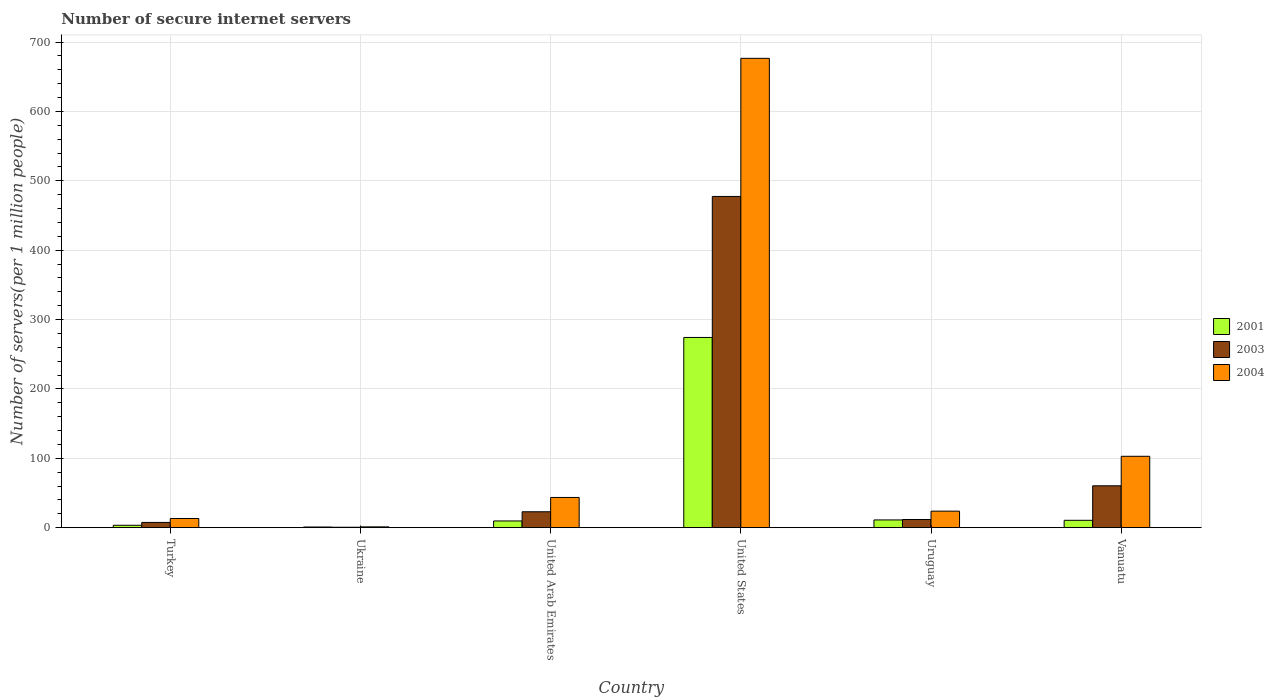How many different coloured bars are there?
Provide a short and direct response. 3. Are the number of bars per tick equal to the number of legend labels?
Ensure brevity in your answer.  Yes. How many bars are there on the 1st tick from the left?
Give a very brief answer. 3. How many bars are there on the 3rd tick from the right?
Offer a terse response. 3. What is the number of secure internet servers in 2003 in United States?
Provide a short and direct response. 477.46. Across all countries, what is the maximum number of secure internet servers in 2004?
Offer a very short reply. 676.55. Across all countries, what is the minimum number of secure internet servers in 2003?
Ensure brevity in your answer.  0.59. In which country was the number of secure internet servers in 2004 maximum?
Keep it short and to the point. United States. In which country was the number of secure internet servers in 2004 minimum?
Provide a short and direct response. Ukraine. What is the total number of secure internet servers in 2004 in the graph?
Your response must be concise. 860.98. What is the difference between the number of secure internet servers in 2001 in Turkey and that in Uruguay?
Give a very brief answer. -7.71. What is the difference between the number of secure internet servers in 2001 in Vanuatu and the number of secure internet servers in 2003 in Turkey?
Keep it short and to the point. 3.06. What is the average number of secure internet servers in 2001 per country?
Ensure brevity in your answer.  51.63. What is the difference between the number of secure internet servers of/in 2004 and number of secure internet servers of/in 2003 in Uruguay?
Provide a succinct answer. 12.04. What is the ratio of the number of secure internet servers in 2004 in Ukraine to that in United Arab Emirates?
Provide a succinct answer. 0.03. Is the difference between the number of secure internet servers in 2004 in Ukraine and Uruguay greater than the difference between the number of secure internet servers in 2003 in Ukraine and Uruguay?
Your response must be concise. No. What is the difference between the highest and the second highest number of secure internet servers in 2001?
Offer a terse response. 263.04. What is the difference between the highest and the lowest number of secure internet servers in 2001?
Make the answer very short. 273.25. What does the 2nd bar from the left in Uruguay represents?
Provide a short and direct response. 2003. How many bars are there?
Give a very brief answer. 18. Are all the bars in the graph horizontal?
Make the answer very short. No. How many countries are there in the graph?
Your response must be concise. 6. Are the values on the major ticks of Y-axis written in scientific E-notation?
Ensure brevity in your answer.  No. Does the graph contain any zero values?
Keep it short and to the point. No. How are the legend labels stacked?
Provide a short and direct response. Vertical. What is the title of the graph?
Your answer should be compact. Number of secure internet servers. Does "1978" appear as one of the legend labels in the graph?
Offer a very short reply. No. What is the label or title of the Y-axis?
Provide a short and direct response. Number of servers(per 1 million people). What is the Number of servers(per 1 million people) in 2001 in Turkey?
Ensure brevity in your answer.  3.41. What is the Number of servers(per 1 million people) in 2003 in Turkey?
Make the answer very short. 7.51. What is the Number of servers(per 1 million people) of 2004 in Turkey?
Provide a short and direct response. 13.17. What is the Number of servers(per 1 million people) of 2001 in Ukraine?
Your answer should be compact. 0.9. What is the Number of servers(per 1 million people) of 2003 in Ukraine?
Offer a terse response. 0.59. What is the Number of servers(per 1 million people) in 2004 in Ukraine?
Give a very brief answer. 1.12. What is the Number of servers(per 1 million people) in 2001 in United Arab Emirates?
Your response must be concise. 9.63. What is the Number of servers(per 1 million people) in 2003 in United Arab Emirates?
Make the answer very short. 22.89. What is the Number of servers(per 1 million people) of 2004 in United Arab Emirates?
Your response must be concise. 43.51. What is the Number of servers(per 1 million people) of 2001 in United States?
Provide a succinct answer. 274.16. What is the Number of servers(per 1 million people) in 2003 in United States?
Your answer should be very brief. 477.46. What is the Number of servers(per 1 million people) of 2004 in United States?
Provide a short and direct response. 676.55. What is the Number of servers(per 1 million people) of 2001 in Uruguay?
Your answer should be very brief. 11.12. What is the Number of servers(per 1 million people) in 2003 in Uruguay?
Offer a very short reply. 11.73. What is the Number of servers(per 1 million people) in 2004 in Uruguay?
Make the answer very short. 23.77. What is the Number of servers(per 1 million people) in 2001 in Vanuatu?
Offer a terse response. 10.57. What is the Number of servers(per 1 million people) of 2003 in Vanuatu?
Provide a short and direct response. 60.31. What is the Number of servers(per 1 million people) of 2004 in Vanuatu?
Offer a very short reply. 102.87. Across all countries, what is the maximum Number of servers(per 1 million people) in 2001?
Keep it short and to the point. 274.16. Across all countries, what is the maximum Number of servers(per 1 million people) in 2003?
Your answer should be very brief. 477.46. Across all countries, what is the maximum Number of servers(per 1 million people) in 2004?
Make the answer very short. 676.55. Across all countries, what is the minimum Number of servers(per 1 million people) in 2001?
Ensure brevity in your answer.  0.9. Across all countries, what is the minimum Number of servers(per 1 million people) in 2003?
Offer a very short reply. 0.59. Across all countries, what is the minimum Number of servers(per 1 million people) in 2004?
Keep it short and to the point. 1.12. What is the total Number of servers(per 1 million people) in 2001 in the graph?
Provide a succinct answer. 309.79. What is the total Number of servers(per 1 million people) of 2003 in the graph?
Your answer should be very brief. 580.48. What is the total Number of servers(per 1 million people) in 2004 in the graph?
Your answer should be very brief. 860.98. What is the difference between the Number of servers(per 1 million people) in 2001 in Turkey and that in Ukraine?
Make the answer very short. 2.51. What is the difference between the Number of servers(per 1 million people) of 2003 in Turkey and that in Ukraine?
Keep it short and to the point. 6.92. What is the difference between the Number of servers(per 1 million people) in 2004 in Turkey and that in Ukraine?
Ensure brevity in your answer.  12.05. What is the difference between the Number of servers(per 1 million people) in 2001 in Turkey and that in United Arab Emirates?
Offer a terse response. -6.22. What is the difference between the Number of servers(per 1 million people) of 2003 in Turkey and that in United Arab Emirates?
Offer a very short reply. -15.38. What is the difference between the Number of servers(per 1 million people) of 2004 in Turkey and that in United Arab Emirates?
Make the answer very short. -30.34. What is the difference between the Number of servers(per 1 million people) in 2001 in Turkey and that in United States?
Ensure brevity in your answer.  -270.74. What is the difference between the Number of servers(per 1 million people) in 2003 in Turkey and that in United States?
Keep it short and to the point. -469.95. What is the difference between the Number of servers(per 1 million people) of 2004 in Turkey and that in United States?
Keep it short and to the point. -663.38. What is the difference between the Number of servers(per 1 million people) of 2001 in Turkey and that in Uruguay?
Your response must be concise. -7.71. What is the difference between the Number of servers(per 1 million people) in 2003 in Turkey and that in Uruguay?
Give a very brief answer. -4.22. What is the difference between the Number of servers(per 1 million people) in 2004 in Turkey and that in Uruguay?
Offer a very short reply. -10.6. What is the difference between the Number of servers(per 1 million people) in 2001 in Turkey and that in Vanuatu?
Provide a succinct answer. -7.15. What is the difference between the Number of servers(per 1 million people) in 2003 in Turkey and that in Vanuatu?
Give a very brief answer. -52.8. What is the difference between the Number of servers(per 1 million people) in 2004 in Turkey and that in Vanuatu?
Offer a terse response. -89.7. What is the difference between the Number of servers(per 1 million people) in 2001 in Ukraine and that in United Arab Emirates?
Provide a succinct answer. -8.73. What is the difference between the Number of servers(per 1 million people) of 2003 in Ukraine and that in United Arab Emirates?
Make the answer very short. -22.31. What is the difference between the Number of servers(per 1 million people) of 2004 in Ukraine and that in United Arab Emirates?
Offer a very short reply. -42.39. What is the difference between the Number of servers(per 1 million people) of 2001 in Ukraine and that in United States?
Keep it short and to the point. -273.25. What is the difference between the Number of servers(per 1 million people) in 2003 in Ukraine and that in United States?
Provide a succinct answer. -476.87. What is the difference between the Number of servers(per 1 million people) in 2004 in Ukraine and that in United States?
Your response must be concise. -675.43. What is the difference between the Number of servers(per 1 million people) in 2001 in Ukraine and that in Uruguay?
Your response must be concise. -10.22. What is the difference between the Number of servers(per 1 million people) of 2003 in Ukraine and that in Uruguay?
Give a very brief answer. -11.14. What is the difference between the Number of servers(per 1 million people) of 2004 in Ukraine and that in Uruguay?
Give a very brief answer. -22.65. What is the difference between the Number of servers(per 1 million people) in 2001 in Ukraine and that in Vanuatu?
Your answer should be compact. -9.66. What is the difference between the Number of servers(per 1 million people) of 2003 in Ukraine and that in Vanuatu?
Your response must be concise. -59.73. What is the difference between the Number of servers(per 1 million people) of 2004 in Ukraine and that in Vanuatu?
Offer a terse response. -101.75. What is the difference between the Number of servers(per 1 million people) in 2001 in United Arab Emirates and that in United States?
Your response must be concise. -264.52. What is the difference between the Number of servers(per 1 million people) in 2003 in United Arab Emirates and that in United States?
Provide a succinct answer. -454.57. What is the difference between the Number of servers(per 1 million people) in 2004 in United Arab Emirates and that in United States?
Give a very brief answer. -633.04. What is the difference between the Number of servers(per 1 million people) of 2001 in United Arab Emirates and that in Uruguay?
Provide a succinct answer. -1.49. What is the difference between the Number of servers(per 1 million people) in 2003 in United Arab Emirates and that in Uruguay?
Provide a short and direct response. 11.16. What is the difference between the Number of servers(per 1 million people) of 2004 in United Arab Emirates and that in Uruguay?
Ensure brevity in your answer.  19.75. What is the difference between the Number of servers(per 1 million people) of 2001 in United Arab Emirates and that in Vanuatu?
Provide a short and direct response. -0.93. What is the difference between the Number of servers(per 1 million people) of 2003 in United Arab Emirates and that in Vanuatu?
Provide a succinct answer. -37.42. What is the difference between the Number of servers(per 1 million people) in 2004 in United Arab Emirates and that in Vanuatu?
Ensure brevity in your answer.  -59.36. What is the difference between the Number of servers(per 1 million people) in 2001 in United States and that in Uruguay?
Give a very brief answer. 263.04. What is the difference between the Number of servers(per 1 million people) of 2003 in United States and that in Uruguay?
Provide a succinct answer. 465.73. What is the difference between the Number of servers(per 1 million people) in 2004 in United States and that in Uruguay?
Provide a succinct answer. 652.79. What is the difference between the Number of servers(per 1 million people) in 2001 in United States and that in Vanuatu?
Keep it short and to the point. 263.59. What is the difference between the Number of servers(per 1 million people) in 2003 in United States and that in Vanuatu?
Ensure brevity in your answer.  417.14. What is the difference between the Number of servers(per 1 million people) of 2004 in United States and that in Vanuatu?
Provide a short and direct response. 573.68. What is the difference between the Number of servers(per 1 million people) of 2001 in Uruguay and that in Vanuatu?
Provide a succinct answer. 0.55. What is the difference between the Number of servers(per 1 million people) in 2003 in Uruguay and that in Vanuatu?
Ensure brevity in your answer.  -48.59. What is the difference between the Number of servers(per 1 million people) in 2004 in Uruguay and that in Vanuatu?
Your response must be concise. -79.1. What is the difference between the Number of servers(per 1 million people) of 2001 in Turkey and the Number of servers(per 1 million people) of 2003 in Ukraine?
Your answer should be compact. 2.83. What is the difference between the Number of servers(per 1 million people) in 2001 in Turkey and the Number of servers(per 1 million people) in 2004 in Ukraine?
Keep it short and to the point. 2.3. What is the difference between the Number of servers(per 1 million people) in 2003 in Turkey and the Number of servers(per 1 million people) in 2004 in Ukraine?
Give a very brief answer. 6.39. What is the difference between the Number of servers(per 1 million people) of 2001 in Turkey and the Number of servers(per 1 million people) of 2003 in United Arab Emirates?
Your response must be concise. -19.48. What is the difference between the Number of servers(per 1 million people) in 2001 in Turkey and the Number of servers(per 1 million people) in 2004 in United Arab Emirates?
Give a very brief answer. -40.1. What is the difference between the Number of servers(per 1 million people) in 2003 in Turkey and the Number of servers(per 1 million people) in 2004 in United Arab Emirates?
Give a very brief answer. -36. What is the difference between the Number of servers(per 1 million people) of 2001 in Turkey and the Number of servers(per 1 million people) of 2003 in United States?
Provide a short and direct response. -474.04. What is the difference between the Number of servers(per 1 million people) of 2001 in Turkey and the Number of servers(per 1 million people) of 2004 in United States?
Your answer should be very brief. -673.14. What is the difference between the Number of servers(per 1 million people) in 2003 in Turkey and the Number of servers(per 1 million people) in 2004 in United States?
Keep it short and to the point. -669.04. What is the difference between the Number of servers(per 1 million people) of 2001 in Turkey and the Number of servers(per 1 million people) of 2003 in Uruguay?
Your answer should be very brief. -8.31. What is the difference between the Number of servers(per 1 million people) of 2001 in Turkey and the Number of servers(per 1 million people) of 2004 in Uruguay?
Keep it short and to the point. -20.35. What is the difference between the Number of servers(per 1 million people) of 2003 in Turkey and the Number of servers(per 1 million people) of 2004 in Uruguay?
Provide a succinct answer. -16.26. What is the difference between the Number of servers(per 1 million people) in 2001 in Turkey and the Number of servers(per 1 million people) in 2003 in Vanuatu?
Make the answer very short. -56.9. What is the difference between the Number of servers(per 1 million people) of 2001 in Turkey and the Number of servers(per 1 million people) of 2004 in Vanuatu?
Provide a short and direct response. -99.46. What is the difference between the Number of servers(per 1 million people) of 2003 in Turkey and the Number of servers(per 1 million people) of 2004 in Vanuatu?
Offer a terse response. -95.36. What is the difference between the Number of servers(per 1 million people) of 2001 in Ukraine and the Number of servers(per 1 million people) of 2003 in United Arab Emirates?
Offer a terse response. -21.99. What is the difference between the Number of servers(per 1 million people) in 2001 in Ukraine and the Number of servers(per 1 million people) in 2004 in United Arab Emirates?
Offer a terse response. -42.61. What is the difference between the Number of servers(per 1 million people) of 2003 in Ukraine and the Number of servers(per 1 million people) of 2004 in United Arab Emirates?
Keep it short and to the point. -42.93. What is the difference between the Number of servers(per 1 million people) in 2001 in Ukraine and the Number of servers(per 1 million people) in 2003 in United States?
Provide a succinct answer. -476.55. What is the difference between the Number of servers(per 1 million people) of 2001 in Ukraine and the Number of servers(per 1 million people) of 2004 in United States?
Your answer should be compact. -675.65. What is the difference between the Number of servers(per 1 million people) of 2003 in Ukraine and the Number of servers(per 1 million people) of 2004 in United States?
Your answer should be compact. -675.97. What is the difference between the Number of servers(per 1 million people) of 2001 in Ukraine and the Number of servers(per 1 million people) of 2003 in Uruguay?
Provide a succinct answer. -10.82. What is the difference between the Number of servers(per 1 million people) of 2001 in Ukraine and the Number of servers(per 1 million people) of 2004 in Uruguay?
Provide a succinct answer. -22.86. What is the difference between the Number of servers(per 1 million people) of 2003 in Ukraine and the Number of servers(per 1 million people) of 2004 in Uruguay?
Offer a terse response. -23.18. What is the difference between the Number of servers(per 1 million people) in 2001 in Ukraine and the Number of servers(per 1 million people) in 2003 in Vanuatu?
Give a very brief answer. -59.41. What is the difference between the Number of servers(per 1 million people) of 2001 in Ukraine and the Number of servers(per 1 million people) of 2004 in Vanuatu?
Your response must be concise. -101.96. What is the difference between the Number of servers(per 1 million people) of 2003 in Ukraine and the Number of servers(per 1 million people) of 2004 in Vanuatu?
Offer a terse response. -102.28. What is the difference between the Number of servers(per 1 million people) in 2001 in United Arab Emirates and the Number of servers(per 1 million people) in 2003 in United States?
Your answer should be very brief. -467.82. What is the difference between the Number of servers(per 1 million people) of 2001 in United Arab Emirates and the Number of servers(per 1 million people) of 2004 in United States?
Make the answer very short. -666.92. What is the difference between the Number of servers(per 1 million people) of 2003 in United Arab Emirates and the Number of servers(per 1 million people) of 2004 in United States?
Provide a short and direct response. -653.66. What is the difference between the Number of servers(per 1 million people) in 2001 in United Arab Emirates and the Number of servers(per 1 million people) in 2003 in Uruguay?
Offer a terse response. -2.09. What is the difference between the Number of servers(per 1 million people) of 2001 in United Arab Emirates and the Number of servers(per 1 million people) of 2004 in Uruguay?
Your answer should be compact. -14.13. What is the difference between the Number of servers(per 1 million people) in 2003 in United Arab Emirates and the Number of servers(per 1 million people) in 2004 in Uruguay?
Provide a short and direct response. -0.87. What is the difference between the Number of servers(per 1 million people) of 2001 in United Arab Emirates and the Number of servers(per 1 million people) of 2003 in Vanuatu?
Provide a succinct answer. -50.68. What is the difference between the Number of servers(per 1 million people) of 2001 in United Arab Emirates and the Number of servers(per 1 million people) of 2004 in Vanuatu?
Offer a very short reply. -93.23. What is the difference between the Number of servers(per 1 million people) of 2003 in United Arab Emirates and the Number of servers(per 1 million people) of 2004 in Vanuatu?
Provide a succinct answer. -79.98. What is the difference between the Number of servers(per 1 million people) of 2001 in United States and the Number of servers(per 1 million people) of 2003 in Uruguay?
Make the answer very short. 262.43. What is the difference between the Number of servers(per 1 million people) in 2001 in United States and the Number of servers(per 1 million people) in 2004 in Uruguay?
Ensure brevity in your answer.  250.39. What is the difference between the Number of servers(per 1 million people) in 2003 in United States and the Number of servers(per 1 million people) in 2004 in Uruguay?
Make the answer very short. 453.69. What is the difference between the Number of servers(per 1 million people) in 2001 in United States and the Number of servers(per 1 million people) in 2003 in Vanuatu?
Provide a succinct answer. 213.84. What is the difference between the Number of servers(per 1 million people) of 2001 in United States and the Number of servers(per 1 million people) of 2004 in Vanuatu?
Provide a succinct answer. 171.29. What is the difference between the Number of servers(per 1 million people) of 2003 in United States and the Number of servers(per 1 million people) of 2004 in Vanuatu?
Your response must be concise. 374.59. What is the difference between the Number of servers(per 1 million people) in 2001 in Uruguay and the Number of servers(per 1 million people) in 2003 in Vanuatu?
Your answer should be compact. -49.19. What is the difference between the Number of servers(per 1 million people) in 2001 in Uruguay and the Number of servers(per 1 million people) in 2004 in Vanuatu?
Keep it short and to the point. -91.75. What is the difference between the Number of servers(per 1 million people) in 2003 in Uruguay and the Number of servers(per 1 million people) in 2004 in Vanuatu?
Your response must be concise. -91.14. What is the average Number of servers(per 1 million people) of 2001 per country?
Provide a succinct answer. 51.63. What is the average Number of servers(per 1 million people) in 2003 per country?
Your response must be concise. 96.75. What is the average Number of servers(per 1 million people) of 2004 per country?
Your response must be concise. 143.5. What is the difference between the Number of servers(per 1 million people) in 2001 and Number of servers(per 1 million people) in 2003 in Turkey?
Provide a short and direct response. -4.1. What is the difference between the Number of servers(per 1 million people) in 2001 and Number of servers(per 1 million people) in 2004 in Turkey?
Keep it short and to the point. -9.76. What is the difference between the Number of servers(per 1 million people) of 2003 and Number of servers(per 1 million people) of 2004 in Turkey?
Your answer should be compact. -5.66. What is the difference between the Number of servers(per 1 million people) of 2001 and Number of servers(per 1 million people) of 2003 in Ukraine?
Your answer should be very brief. 0.32. What is the difference between the Number of servers(per 1 million people) in 2001 and Number of servers(per 1 million people) in 2004 in Ukraine?
Keep it short and to the point. -0.21. What is the difference between the Number of servers(per 1 million people) of 2003 and Number of servers(per 1 million people) of 2004 in Ukraine?
Make the answer very short. -0.53. What is the difference between the Number of servers(per 1 million people) of 2001 and Number of servers(per 1 million people) of 2003 in United Arab Emirates?
Your response must be concise. -13.26. What is the difference between the Number of servers(per 1 million people) in 2001 and Number of servers(per 1 million people) in 2004 in United Arab Emirates?
Provide a succinct answer. -33.88. What is the difference between the Number of servers(per 1 million people) of 2003 and Number of servers(per 1 million people) of 2004 in United Arab Emirates?
Ensure brevity in your answer.  -20.62. What is the difference between the Number of servers(per 1 million people) in 2001 and Number of servers(per 1 million people) in 2003 in United States?
Your response must be concise. -203.3. What is the difference between the Number of servers(per 1 million people) in 2001 and Number of servers(per 1 million people) in 2004 in United States?
Your response must be concise. -402.4. What is the difference between the Number of servers(per 1 million people) of 2003 and Number of servers(per 1 million people) of 2004 in United States?
Provide a short and direct response. -199.1. What is the difference between the Number of servers(per 1 million people) in 2001 and Number of servers(per 1 million people) in 2003 in Uruguay?
Ensure brevity in your answer.  -0.61. What is the difference between the Number of servers(per 1 million people) in 2001 and Number of servers(per 1 million people) in 2004 in Uruguay?
Provide a short and direct response. -12.65. What is the difference between the Number of servers(per 1 million people) in 2003 and Number of servers(per 1 million people) in 2004 in Uruguay?
Offer a very short reply. -12.04. What is the difference between the Number of servers(per 1 million people) of 2001 and Number of servers(per 1 million people) of 2003 in Vanuatu?
Provide a succinct answer. -49.75. What is the difference between the Number of servers(per 1 million people) of 2001 and Number of servers(per 1 million people) of 2004 in Vanuatu?
Your answer should be compact. -92.3. What is the difference between the Number of servers(per 1 million people) in 2003 and Number of servers(per 1 million people) in 2004 in Vanuatu?
Your response must be concise. -42.56. What is the ratio of the Number of servers(per 1 million people) of 2001 in Turkey to that in Ukraine?
Keep it short and to the point. 3.78. What is the ratio of the Number of servers(per 1 million people) in 2003 in Turkey to that in Ukraine?
Your answer should be compact. 12.82. What is the ratio of the Number of servers(per 1 million people) in 2004 in Turkey to that in Ukraine?
Offer a very short reply. 11.79. What is the ratio of the Number of servers(per 1 million people) in 2001 in Turkey to that in United Arab Emirates?
Your answer should be very brief. 0.35. What is the ratio of the Number of servers(per 1 million people) of 2003 in Turkey to that in United Arab Emirates?
Offer a terse response. 0.33. What is the ratio of the Number of servers(per 1 million people) in 2004 in Turkey to that in United Arab Emirates?
Provide a short and direct response. 0.3. What is the ratio of the Number of servers(per 1 million people) in 2001 in Turkey to that in United States?
Ensure brevity in your answer.  0.01. What is the ratio of the Number of servers(per 1 million people) of 2003 in Turkey to that in United States?
Your response must be concise. 0.02. What is the ratio of the Number of servers(per 1 million people) in 2004 in Turkey to that in United States?
Offer a terse response. 0.02. What is the ratio of the Number of servers(per 1 million people) of 2001 in Turkey to that in Uruguay?
Ensure brevity in your answer.  0.31. What is the ratio of the Number of servers(per 1 million people) in 2003 in Turkey to that in Uruguay?
Ensure brevity in your answer.  0.64. What is the ratio of the Number of servers(per 1 million people) in 2004 in Turkey to that in Uruguay?
Keep it short and to the point. 0.55. What is the ratio of the Number of servers(per 1 million people) in 2001 in Turkey to that in Vanuatu?
Offer a terse response. 0.32. What is the ratio of the Number of servers(per 1 million people) of 2003 in Turkey to that in Vanuatu?
Provide a succinct answer. 0.12. What is the ratio of the Number of servers(per 1 million people) in 2004 in Turkey to that in Vanuatu?
Offer a terse response. 0.13. What is the ratio of the Number of servers(per 1 million people) in 2001 in Ukraine to that in United Arab Emirates?
Offer a very short reply. 0.09. What is the ratio of the Number of servers(per 1 million people) in 2003 in Ukraine to that in United Arab Emirates?
Your answer should be compact. 0.03. What is the ratio of the Number of servers(per 1 million people) of 2004 in Ukraine to that in United Arab Emirates?
Your answer should be compact. 0.03. What is the ratio of the Number of servers(per 1 million people) in 2001 in Ukraine to that in United States?
Your answer should be very brief. 0. What is the ratio of the Number of servers(per 1 million people) of 2003 in Ukraine to that in United States?
Your response must be concise. 0. What is the ratio of the Number of servers(per 1 million people) in 2004 in Ukraine to that in United States?
Offer a very short reply. 0. What is the ratio of the Number of servers(per 1 million people) of 2001 in Ukraine to that in Uruguay?
Ensure brevity in your answer.  0.08. What is the ratio of the Number of servers(per 1 million people) of 2003 in Ukraine to that in Uruguay?
Your answer should be compact. 0.05. What is the ratio of the Number of servers(per 1 million people) in 2004 in Ukraine to that in Uruguay?
Offer a terse response. 0.05. What is the ratio of the Number of servers(per 1 million people) in 2001 in Ukraine to that in Vanuatu?
Keep it short and to the point. 0.09. What is the ratio of the Number of servers(per 1 million people) in 2003 in Ukraine to that in Vanuatu?
Offer a terse response. 0.01. What is the ratio of the Number of servers(per 1 million people) of 2004 in Ukraine to that in Vanuatu?
Keep it short and to the point. 0.01. What is the ratio of the Number of servers(per 1 million people) of 2001 in United Arab Emirates to that in United States?
Ensure brevity in your answer.  0.04. What is the ratio of the Number of servers(per 1 million people) of 2003 in United Arab Emirates to that in United States?
Offer a very short reply. 0.05. What is the ratio of the Number of servers(per 1 million people) in 2004 in United Arab Emirates to that in United States?
Your response must be concise. 0.06. What is the ratio of the Number of servers(per 1 million people) of 2001 in United Arab Emirates to that in Uruguay?
Your answer should be compact. 0.87. What is the ratio of the Number of servers(per 1 million people) in 2003 in United Arab Emirates to that in Uruguay?
Offer a very short reply. 1.95. What is the ratio of the Number of servers(per 1 million people) in 2004 in United Arab Emirates to that in Uruguay?
Offer a terse response. 1.83. What is the ratio of the Number of servers(per 1 million people) of 2001 in United Arab Emirates to that in Vanuatu?
Provide a succinct answer. 0.91. What is the ratio of the Number of servers(per 1 million people) in 2003 in United Arab Emirates to that in Vanuatu?
Provide a succinct answer. 0.38. What is the ratio of the Number of servers(per 1 million people) in 2004 in United Arab Emirates to that in Vanuatu?
Offer a very short reply. 0.42. What is the ratio of the Number of servers(per 1 million people) of 2001 in United States to that in Uruguay?
Offer a very short reply. 24.65. What is the ratio of the Number of servers(per 1 million people) in 2003 in United States to that in Uruguay?
Ensure brevity in your answer.  40.71. What is the ratio of the Number of servers(per 1 million people) of 2004 in United States to that in Uruguay?
Offer a very short reply. 28.47. What is the ratio of the Number of servers(per 1 million people) of 2001 in United States to that in Vanuatu?
Your answer should be very brief. 25.95. What is the ratio of the Number of servers(per 1 million people) of 2003 in United States to that in Vanuatu?
Offer a very short reply. 7.92. What is the ratio of the Number of servers(per 1 million people) in 2004 in United States to that in Vanuatu?
Make the answer very short. 6.58. What is the ratio of the Number of servers(per 1 million people) of 2001 in Uruguay to that in Vanuatu?
Provide a succinct answer. 1.05. What is the ratio of the Number of servers(per 1 million people) of 2003 in Uruguay to that in Vanuatu?
Ensure brevity in your answer.  0.19. What is the ratio of the Number of servers(per 1 million people) in 2004 in Uruguay to that in Vanuatu?
Offer a very short reply. 0.23. What is the difference between the highest and the second highest Number of servers(per 1 million people) of 2001?
Provide a short and direct response. 263.04. What is the difference between the highest and the second highest Number of servers(per 1 million people) of 2003?
Your answer should be very brief. 417.14. What is the difference between the highest and the second highest Number of servers(per 1 million people) of 2004?
Provide a succinct answer. 573.68. What is the difference between the highest and the lowest Number of servers(per 1 million people) of 2001?
Make the answer very short. 273.25. What is the difference between the highest and the lowest Number of servers(per 1 million people) in 2003?
Offer a very short reply. 476.87. What is the difference between the highest and the lowest Number of servers(per 1 million people) in 2004?
Offer a very short reply. 675.43. 